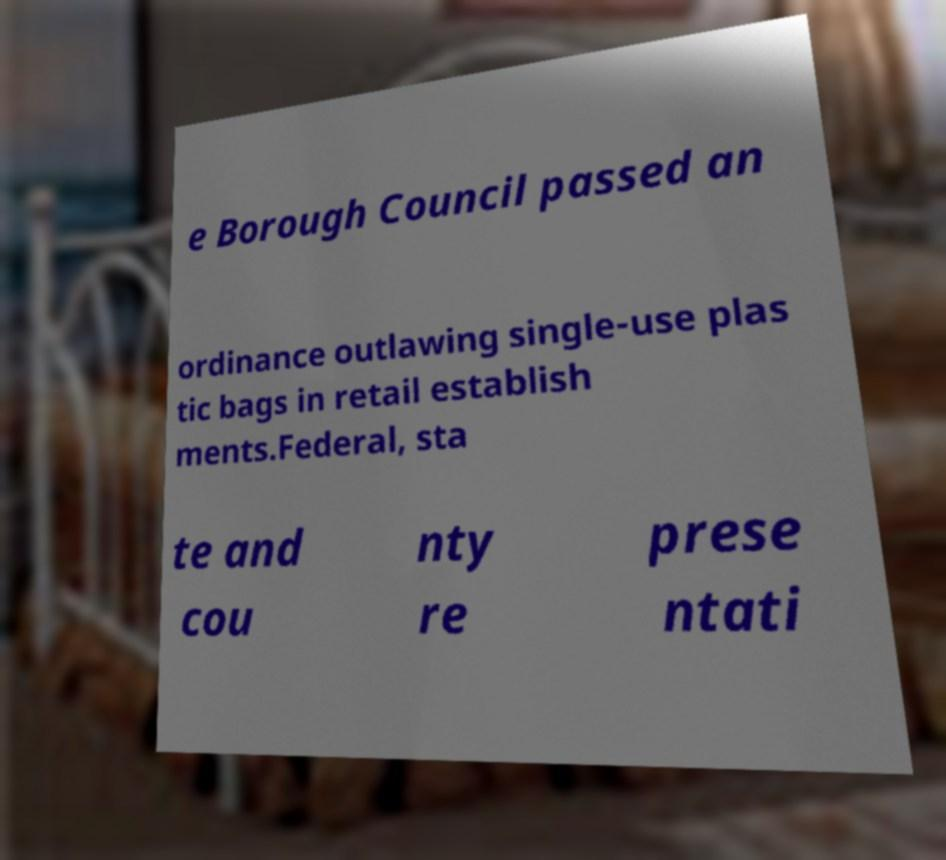There's text embedded in this image that I need extracted. Can you transcribe it verbatim? e Borough Council passed an ordinance outlawing single-use plas tic bags in retail establish ments.Federal, sta te and cou nty re prese ntati 